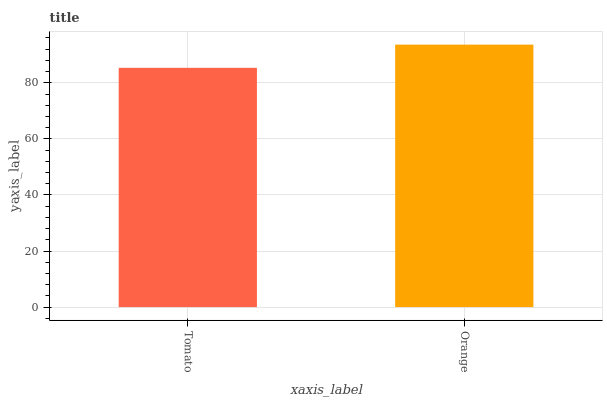Is Orange the minimum?
Answer yes or no. No. Is Orange greater than Tomato?
Answer yes or no. Yes. Is Tomato less than Orange?
Answer yes or no. Yes. Is Tomato greater than Orange?
Answer yes or no. No. Is Orange less than Tomato?
Answer yes or no. No. Is Orange the high median?
Answer yes or no. Yes. Is Tomato the low median?
Answer yes or no. Yes. Is Tomato the high median?
Answer yes or no. No. Is Orange the low median?
Answer yes or no. No. 